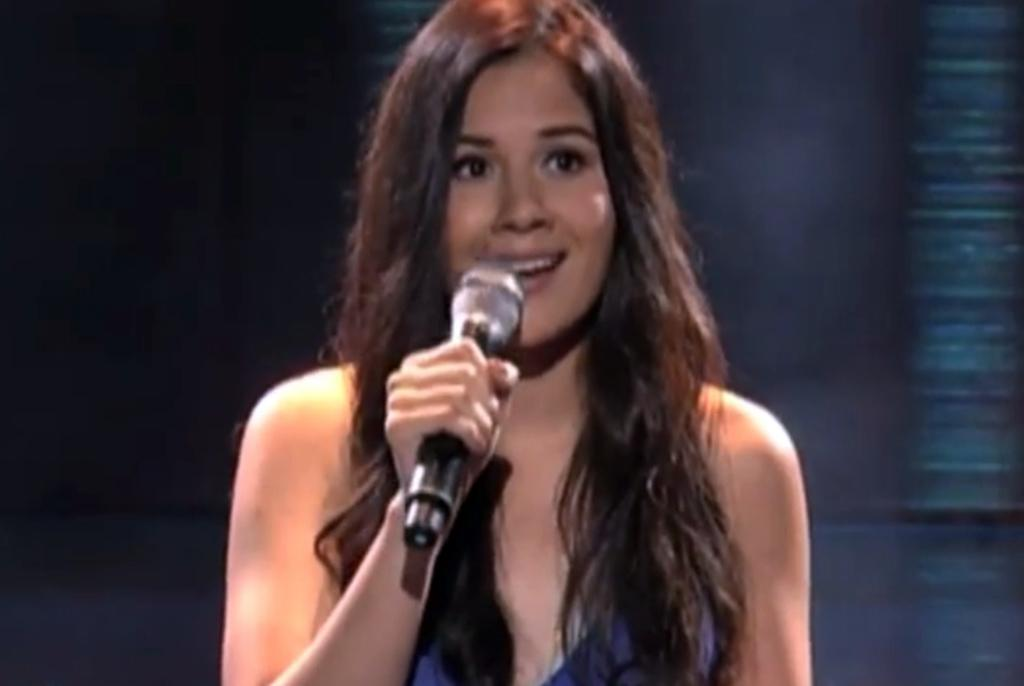Who is the main subject in the image? There is a woman in the image. What is the woman wearing? The woman is wearing a blue dress. What is the woman holding in the image? The woman is holding a mic. What is the name of the church where the woman is giving a speech in the image? There is no church or speech present in the image; it only shows a woman holding a mic while wearing a blue dress. 